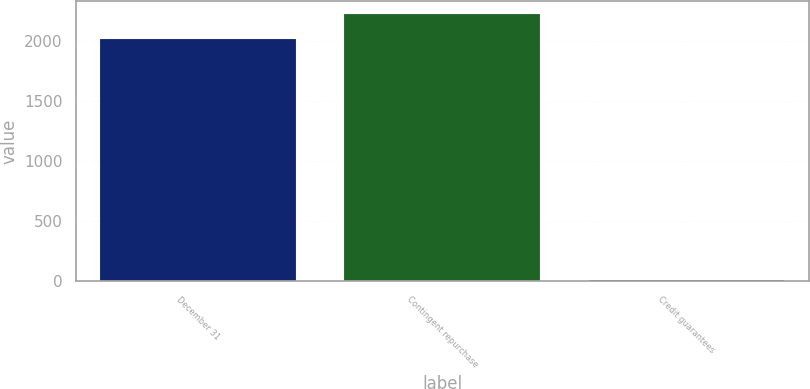Convert chart. <chart><loc_0><loc_0><loc_500><loc_500><bar_chart><fcel>December 31<fcel>Contingent repurchase<fcel>Credit guarantees<nl><fcel>2012<fcel>2217.2<fcel>13<nl></chart> 